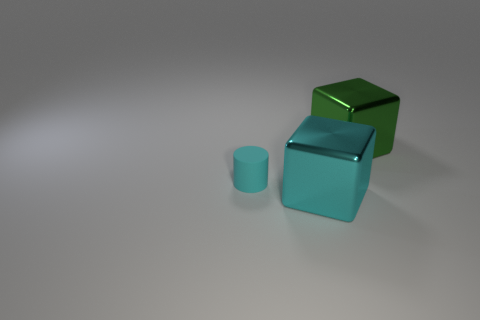Add 3 tiny brown shiny things. How many objects exist? 6 Subtract all cubes. How many objects are left? 1 Subtract all red spheres. How many green cubes are left? 1 Add 3 tiny cyan rubber things. How many tiny cyan rubber things exist? 4 Subtract all green cubes. How many cubes are left? 1 Subtract 1 cyan cylinders. How many objects are left? 2 Subtract 1 cylinders. How many cylinders are left? 0 Subtract all green cylinders. Subtract all purple cubes. How many cylinders are left? 1 Subtract all big green blocks. Subtract all matte things. How many objects are left? 1 Add 3 big blocks. How many big blocks are left? 5 